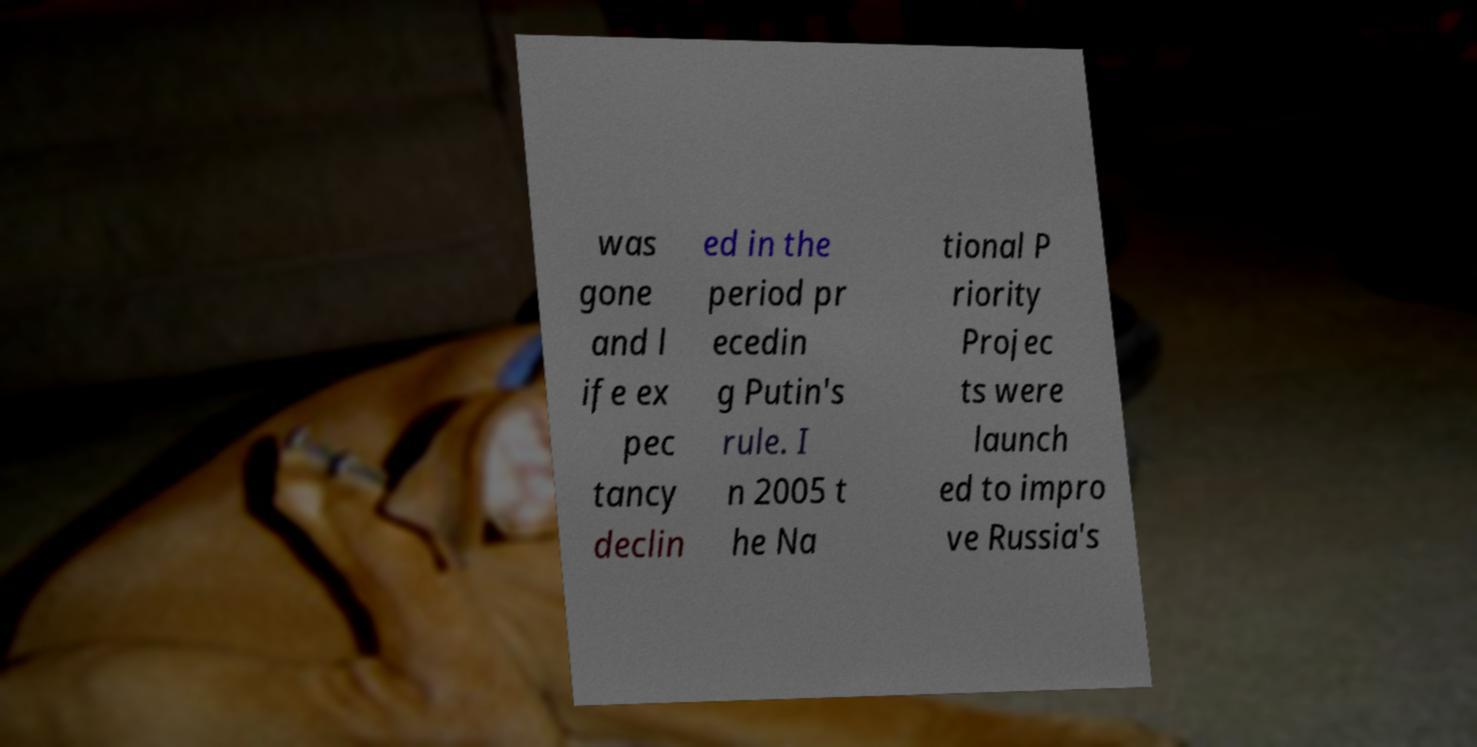Please read and relay the text visible in this image. What does it say? was gone and l ife ex pec tancy declin ed in the period pr ecedin g Putin's rule. I n 2005 t he Na tional P riority Projec ts were launch ed to impro ve Russia's 